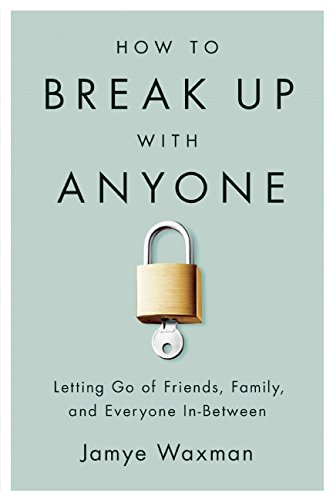Can the advice in this book apply to professional relationships too? Yes, while primarily focused on personal relationships, the principles and advice in this book can be adapted to professionally manage and terminate workplace relationships where necessary. 